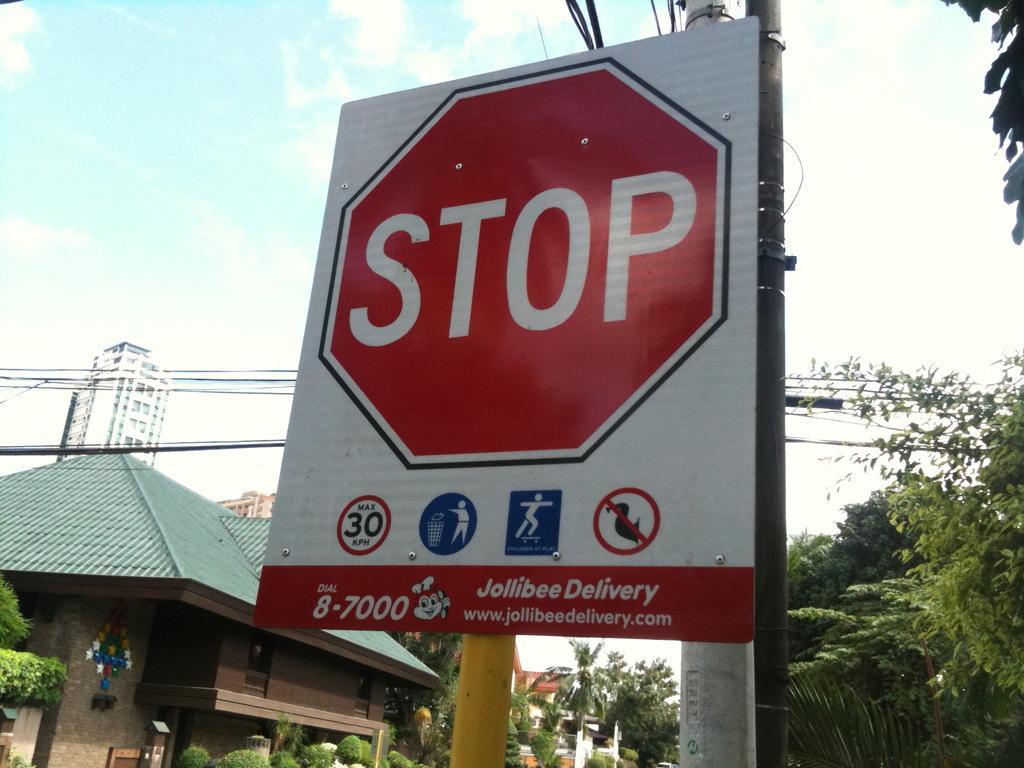In one or two sentences, can you explain what this image depicts? In this image I can see the black colored pole and a yellow colored pole. I can see a board which is white and red in color is attached to the pole. In the background I can see few buildings, few trees, few wires and the sky. 